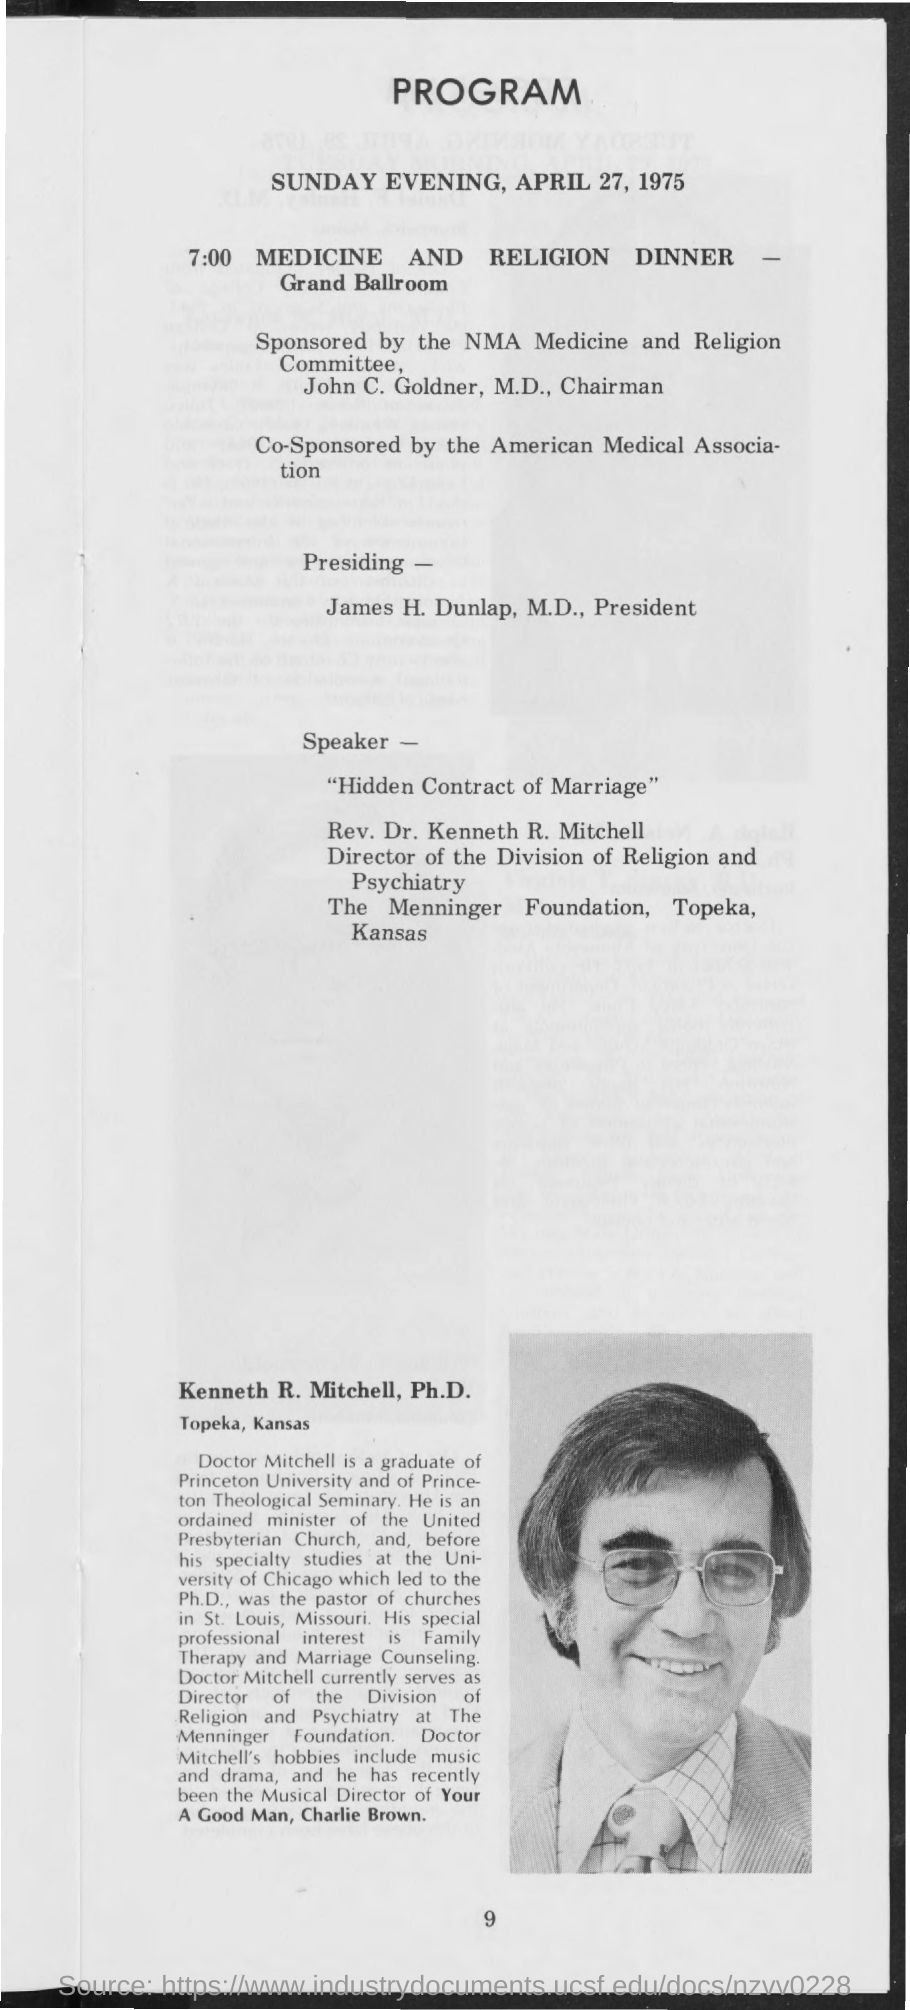When is the program?
Ensure brevity in your answer.  SUNDAY EVENING, APRIL 27, 1975. When is the medicine and religion dinner?
Offer a terse response. 7:00. Where is the medicine and religion dinner?
Provide a short and direct response. GRAND BALLROOM. Who is it co-sponsored by ?
Your answer should be very brief. AMERICAN MEDICAL ASSOCIATION. Who is it presidedby?
Provide a succinct answer. James H. Dunlap, M.D., President. Who is the speaker for "Hidden Contract of marriage"?
Ensure brevity in your answer.  REV. DR. KENNETH R. MITCHELL. 